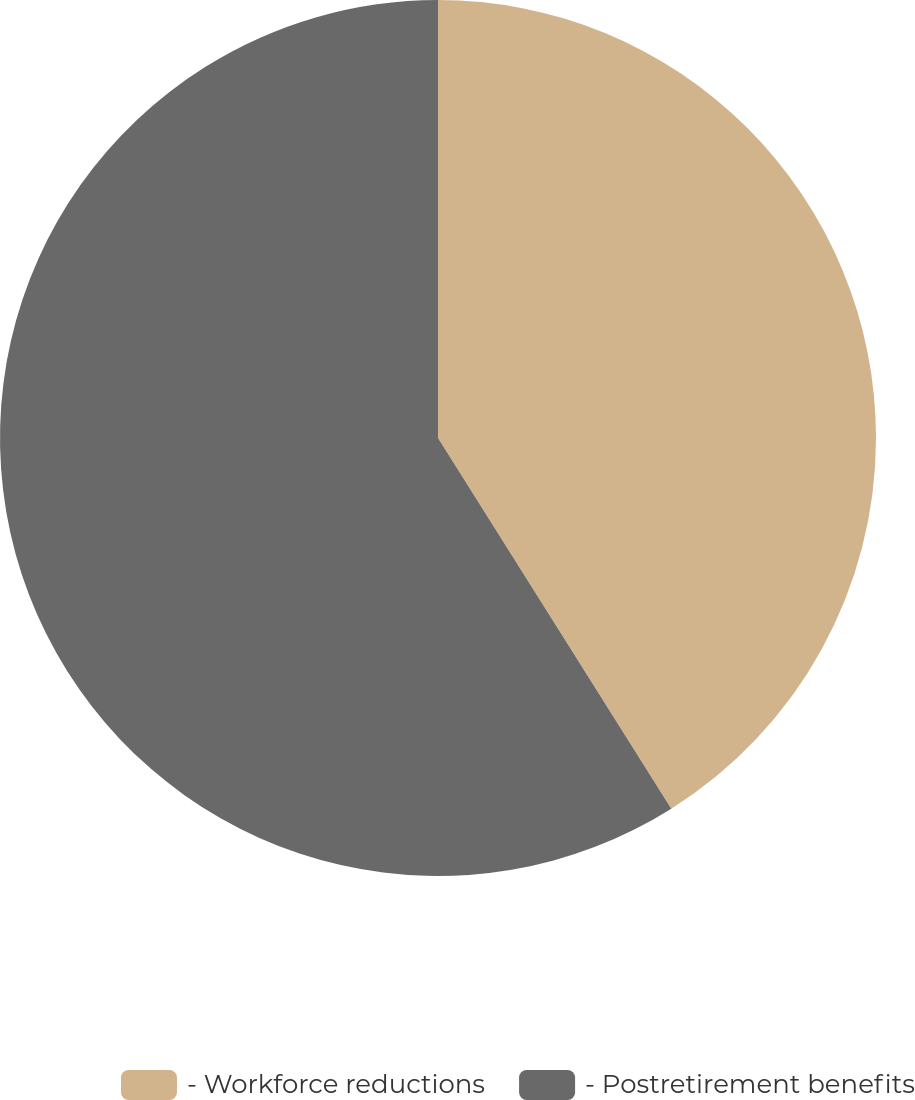Convert chart to OTSL. <chart><loc_0><loc_0><loc_500><loc_500><pie_chart><fcel>- Workforce reductions<fcel>- Postretirement benefits<nl><fcel>41.06%<fcel>58.94%<nl></chart> 